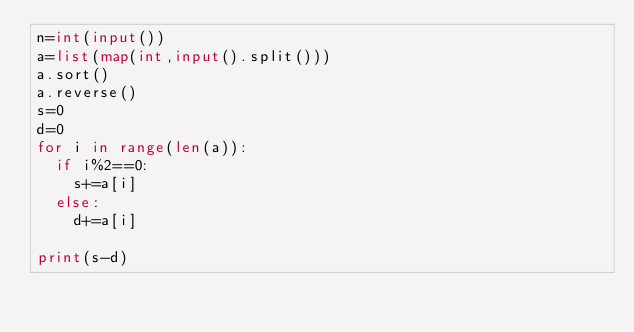Convert code to text. <code><loc_0><loc_0><loc_500><loc_500><_Python_>n=int(input())
a=list(map(int,input().split()))
a.sort()
a.reverse()
s=0
d=0
for i in range(len(a)):
  if i%2==0:
    s+=a[i]
  else:
    d+=a[i]

print(s-d)</code> 